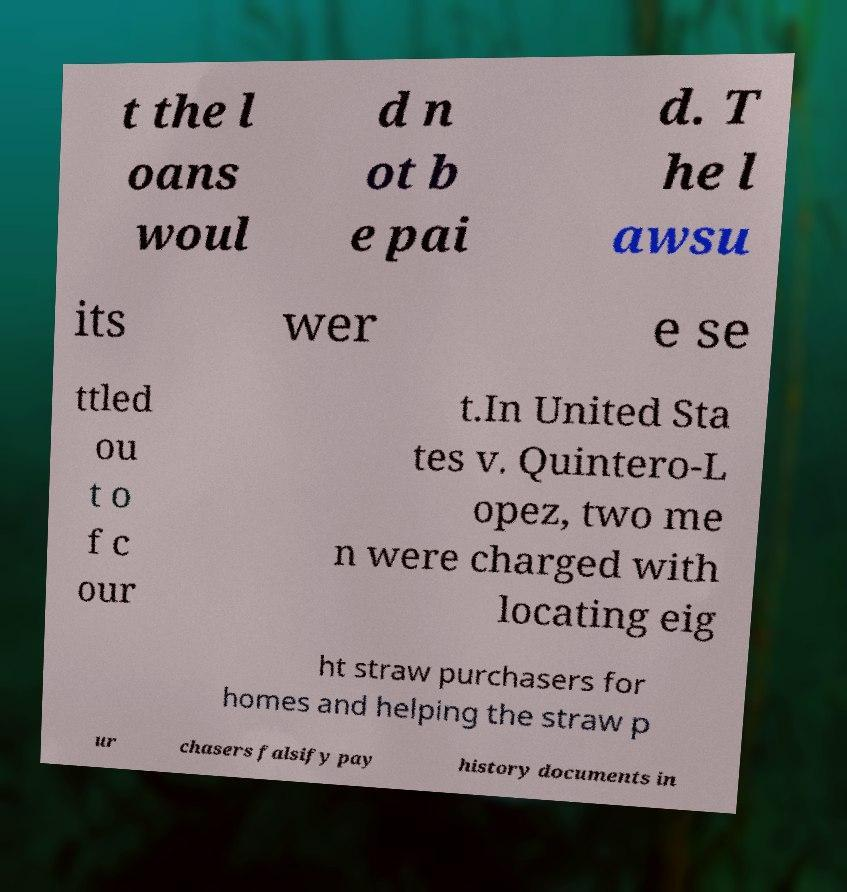Could you assist in decoding the text presented in this image and type it out clearly? t the l oans woul d n ot b e pai d. T he l awsu its wer e se ttled ou t o f c our t.In United Sta tes v. Quintero-L opez, two me n were charged with locating eig ht straw purchasers for homes and helping the straw p ur chasers falsify pay history documents in 